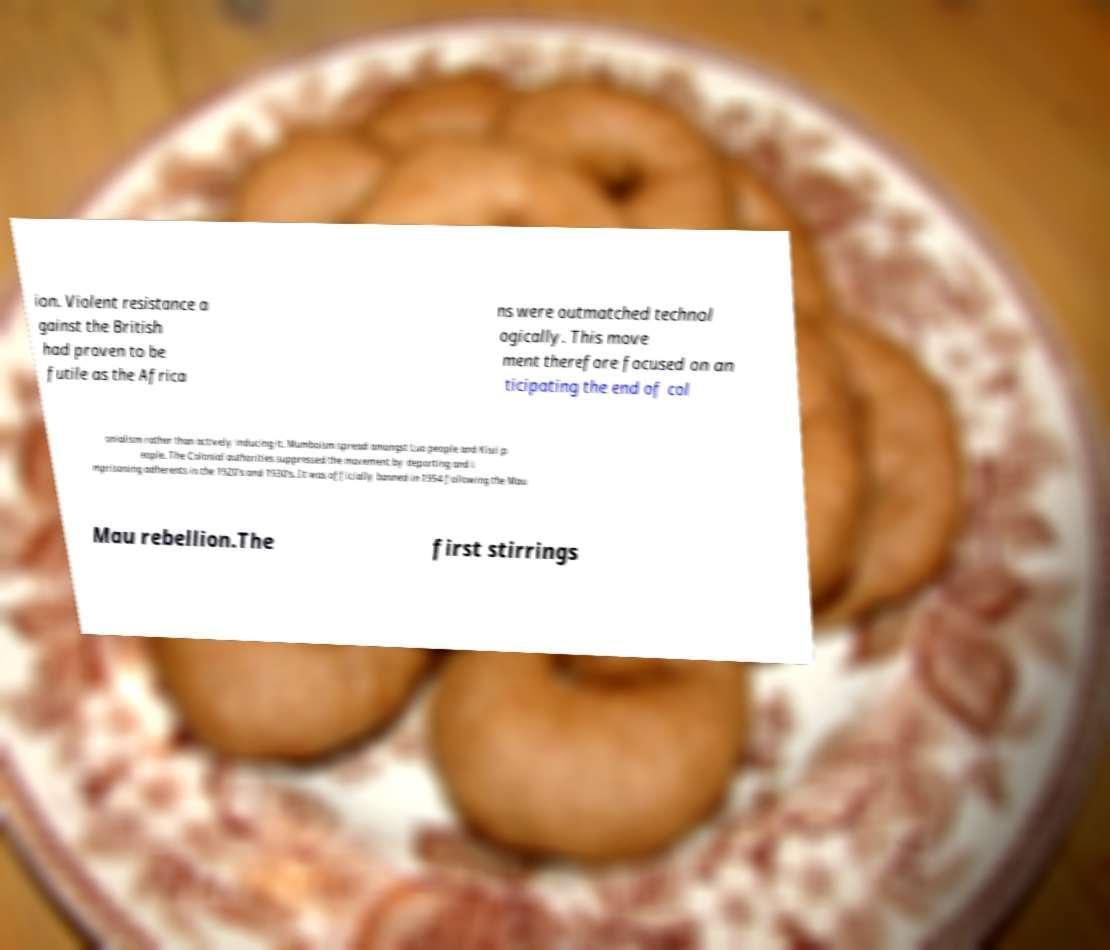Can you accurately transcribe the text from the provided image for me? ion. Violent resistance a gainst the British had proven to be futile as the Africa ns were outmatched technol ogically. This move ment therefore focused on an ticipating the end of col onialism rather than actively inducing it. Mumboism spread amongst Luo people and Kisii p eople. The Colonial authorities suppressed the movement by deporting and i mprisoning adherents in the 1920's and 1930's. It was officially banned in 1954 following the Mau Mau rebellion.The first stirrings 